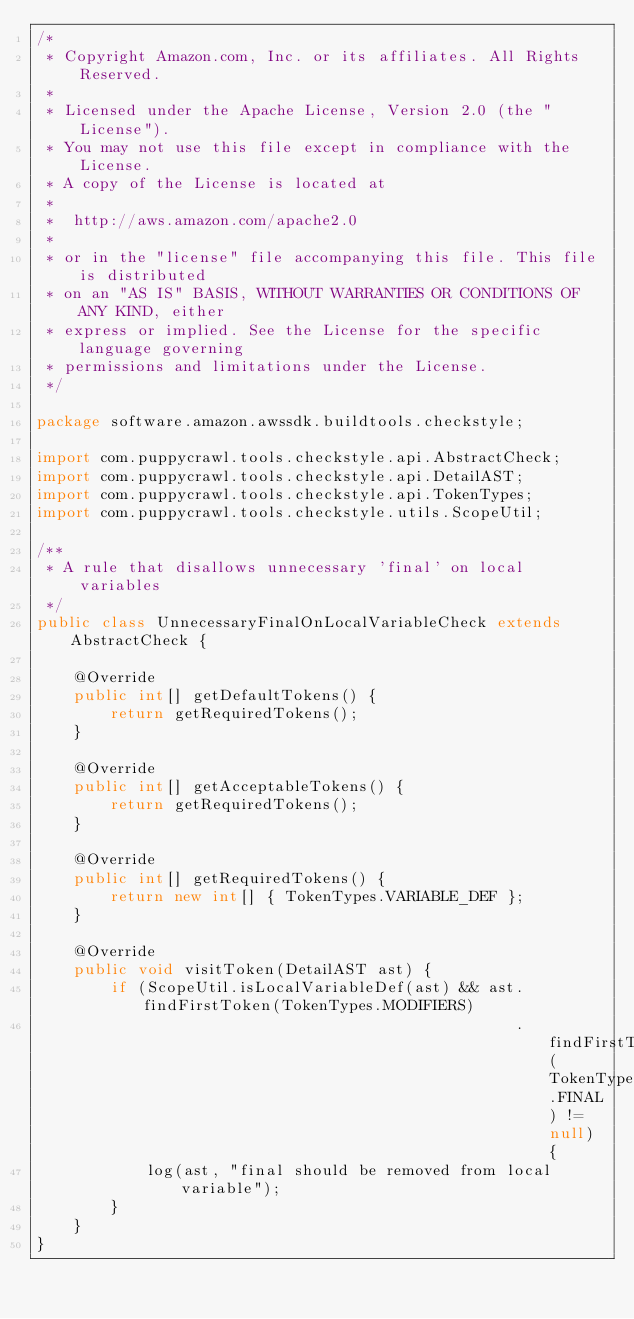Convert code to text. <code><loc_0><loc_0><loc_500><loc_500><_Java_>/*
 * Copyright Amazon.com, Inc. or its affiliates. All Rights Reserved.
 *
 * Licensed under the Apache License, Version 2.0 (the "License").
 * You may not use this file except in compliance with the License.
 * A copy of the License is located at
 *
 *  http://aws.amazon.com/apache2.0
 *
 * or in the "license" file accompanying this file. This file is distributed
 * on an "AS IS" BASIS, WITHOUT WARRANTIES OR CONDITIONS OF ANY KIND, either
 * express or implied. See the License for the specific language governing
 * permissions and limitations under the License.
 */

package software.amazon.awssdk.buildtools.checkstyle;

import com.puppycrawl.tools.checkstyle.api.AbstractCheck;
import com.puppycrawl.tools.checkstyle.api.DetailAST;
import com.puppycrawl.tools.checkstyle.api.TokenTypes;
import com.puppycrawl.tools.checkstyle.utils.ScopeUtil;

/**
 * A rule that disallows unnecessary 'final' on local variables
 */
public class UnnecessaryFinalOnLocalVariableCheck extends AbstractCheck {

    @Override
    public int[] getDefaultTokens() {
        return getRequiredTokens();
    }

    @Override
    public int[] getAcceptableTokens() {
        return getRequiredTokens();
    }

    @Override
    public int[] getRequiredTokens() {
        return new int[] { TokenTypes.VARIABLE_DEF };
    }

    @Override
    public void visitToken(DetailAST ast) {
        if (ScopeUtil.isLocalVariableDef(ast) && ast.findFirstToken(TokenTypes.MODIFIERS)
                                                    .findFirstToken(TokenTypes.FINAL) != null) {
            log(ast, "final should be removed from local variable");
        }
    }
}
</code> 